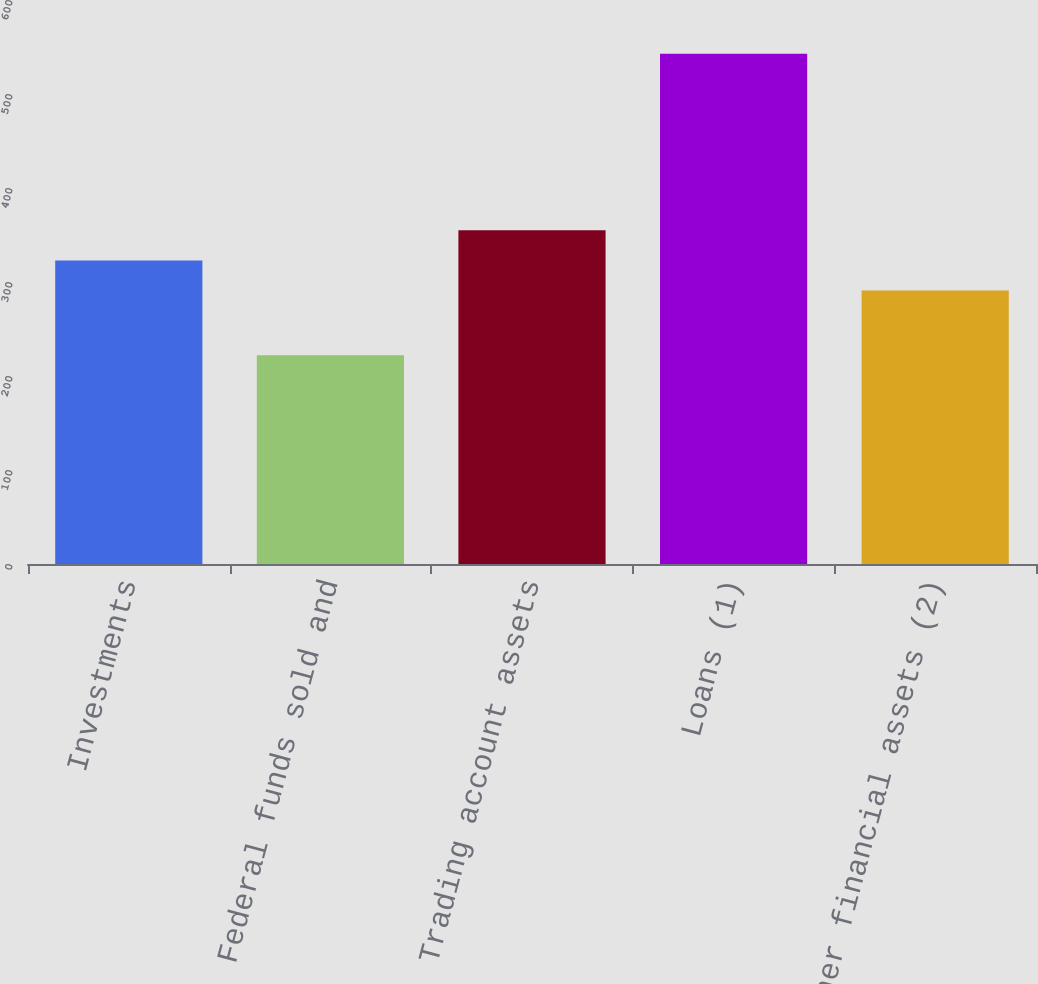<chart> <loc_0><loc_0><loc_500><loc_500><bar_chart><fcel>Investments<fcel>Federal funds sold and<fcel>Trading account assets<fcel>Loans (1)<fcel>Other financial assets (2)<nl><fcel>322.98<fcel>222<fcel>355.06<fcel>542.8<fcel>290.9<nl></chart> 